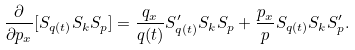Convert formula to latex. <formula><loc_0><loc_0><loc_500><loc_500>\frac { \partial } { \partial p _ { x } } [ S _ { q ( t ) } S _ { k } S _ { p } ] = \frac { q _ { x } } { q ( t ) } S _ { q ( t ) } ^ { \prime } S _ { k } S _ { p } + \frac { p _ { x } } { p } S _ { q ( t ) } S _ { k } S _ { p } ^ { \prime } .</formula> 